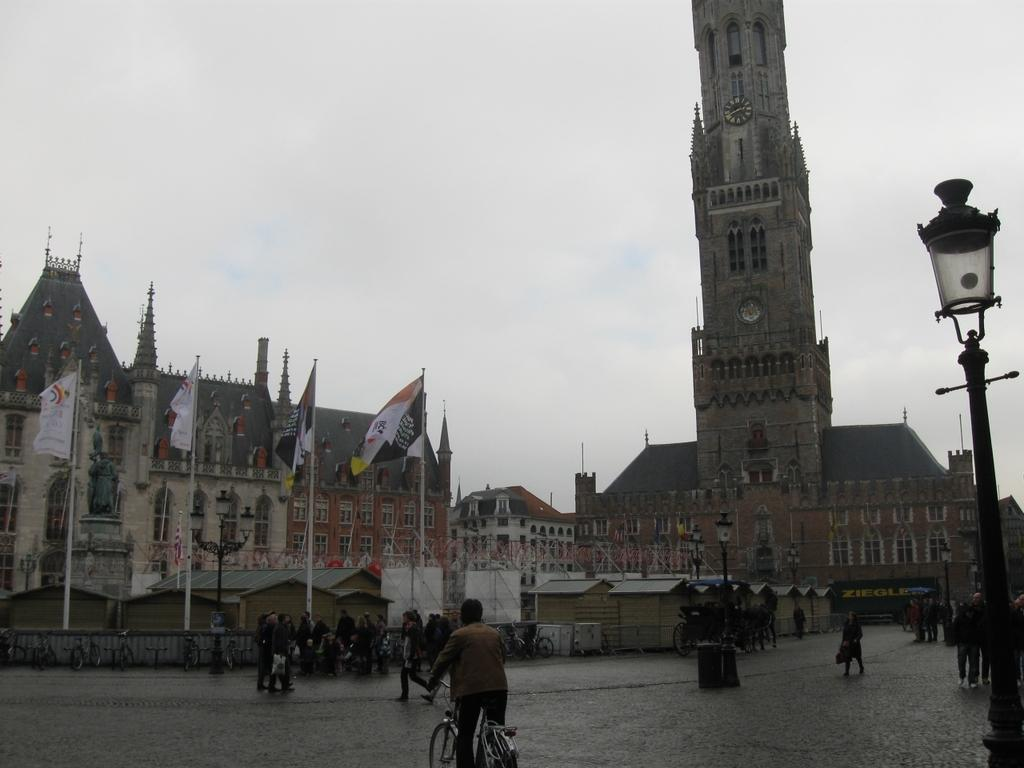What is the main structure in the image? There is a tower in the image. What other type of structure can be seen in the image? There is a building in the image. What are the flags on the ground used for in the image? The flags on the ground are not used for anything specific in the image; they are just present. Can you describe the people in the image? There are people in the image, and some of them are walking on the road. What is the man in the image doing? A man is cycling in the image. How many toes does the flock of birds have in the image? There are no birds or toes present in the image; it features a tower, a building, flags, people, and a man cycling. 